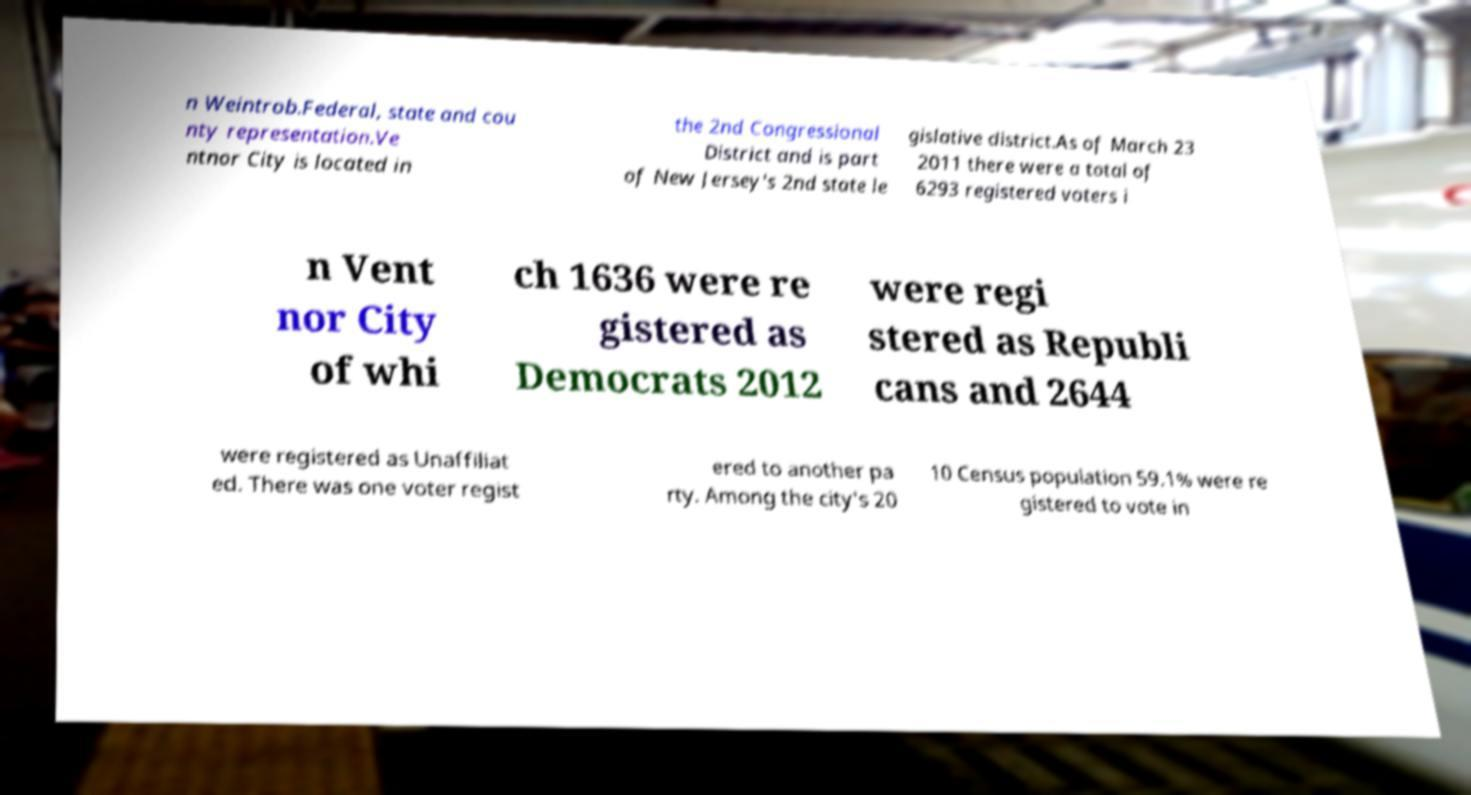There's text embedded in this image that I need extracted. Can you transcribe it verbatim? n Weintrob.Federal, state and cou nty representation.Ve ntnor City is located in the 2nd Congressional District and is part of New Jersey's 2nd state le gislative district.As of March 23 2011 there were a total of 6293 registered voters i n Vent nor City of whi ch 1636 were re gistered as Democrats 2012 were regi stered as Republi cans and 2644 were registered as Unaffiliat ed. There was one voter regist ered to another pa rty. Among the city's 20 10 Census population 59.1% were re gistered to vote in 